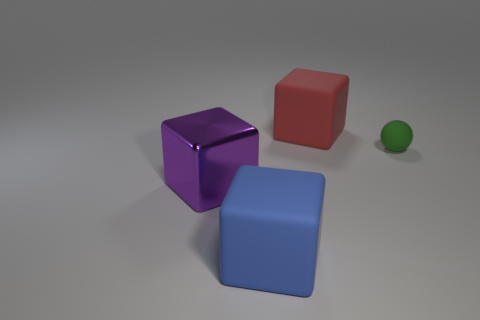Describe the position of the purple block relative to the red one. The purple block is positioned to the left of the red block when viewed from the perspective of the image. If I were to stack the green sphere on top of one of the blocks, which block would be the most stable option? The most stable option for stacking the green sphere would be the blue block because it has the largest visible surface area on top among all the blocks. 